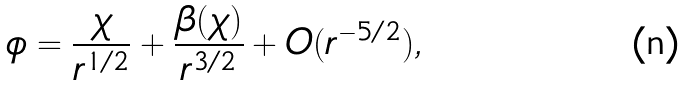<formula> <loc_0><loc_0><loc_500><loc_500>\phi = \frac { \chi } { r ^ { 1 / 2 } } + \frac { \beta ( \chi ) } { r ^ { 3 / 2 } } + O ( r ^ { - 5 / 2 } ) ,</formula> 